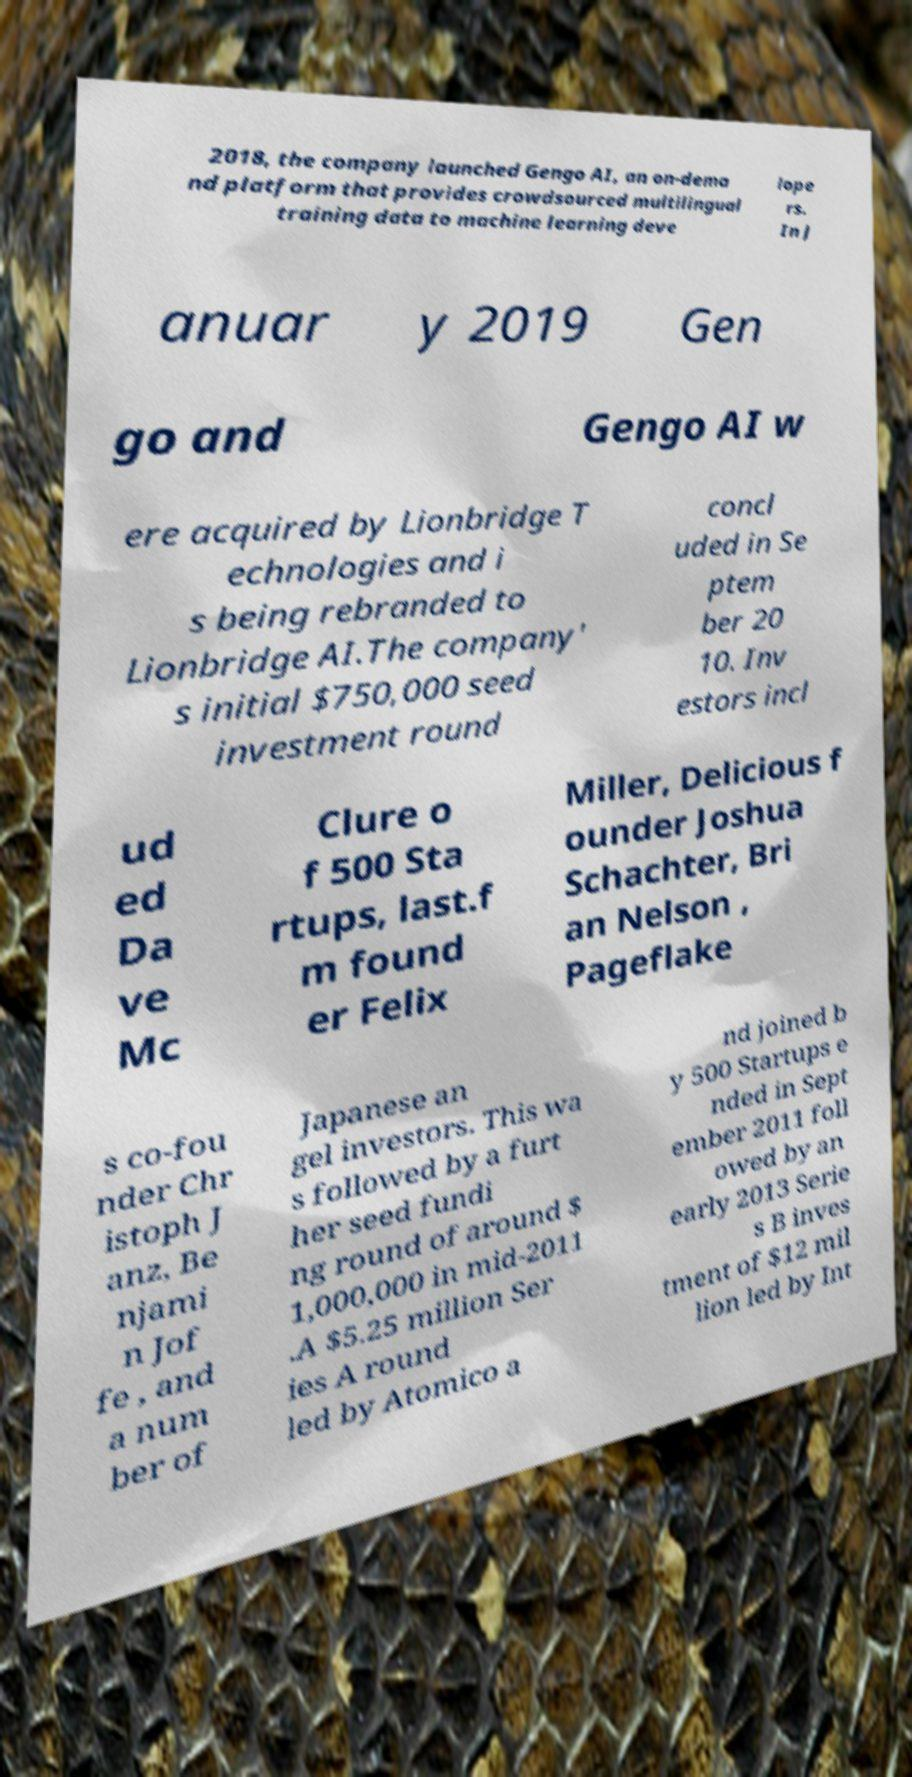Can you read and provide the text displayed in the image?This photo seems to have some interesting text. Can you extract and type it out for me? 2018, the company launched Gengo AI, an on-dema nd platform that provides crowdsourced multilingual training data to machine learning deve lope rs. In J anuar y 2019 Gen go and Gengo AI w ere acquired by Lionbridge T echnologies and i s being rebranded to Lionbridge AI.The company' s initial $750,000 seed investment round concl uded in Se ptem ber 20 10. Inv estors incl ud ed Da ve Mc Clure o f 500 Sta rtups, last.f m found er Felix Miller, Delicious f ounder Joshua Schachter, Bri an Nelson , Pageflake s co-fou nder Chr istoph J anz, Be njami n Jof fe , and a num ber of Japanese an gel investors. This wa s followed by a furt her seed fundi ng round of around $ 1,000,000 in mid-2011 .A $5.25 million Ser ies A round led by Atomico a nd joined b y 500 Startups e nded in Sept ember 2011 foll owed by an early 2013 Serie s B inves tment of $12 mil lion led by Int 